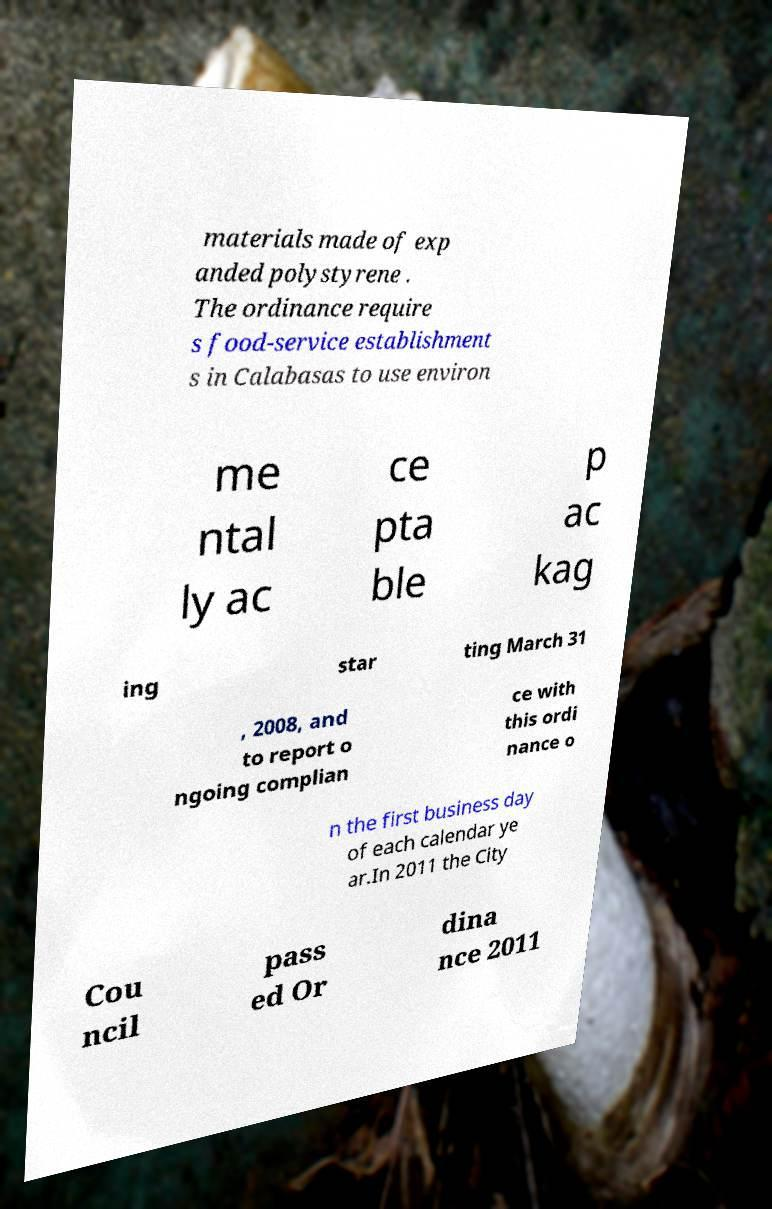I need the written content from this picture converted into text. Can you do that? materials made of exp anded polystyrene . The ordinance require s food-service establishment s in Calabasas to use environ me ntal ly ac ce pta ble p ac kag ing star ting March 31 , 2008, and to report o ngoing complian ce with this ordi nance o n the first business day of each calendar ye ar.In 2011 the City Cou ncil pass ed Or dina nce 2011 